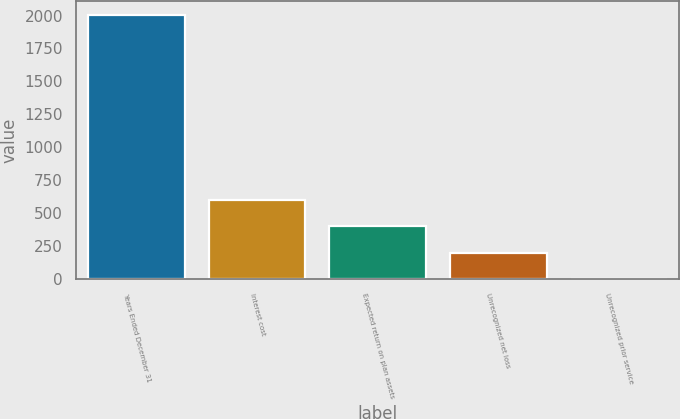Convert chart. <chart><loc_0><loc_0><loc_500><loc_500><bar_chart><fcel>Years Ended December 31<fcel>Interest cost<fcel>Expected return on plan assets<fcel>Unrecognized net loss<fcel>Unrecognized prior service<nl><fcel>2006<fcel>603.2<fcel>402.8<fcel>202.4<fcel>2<nl></chart> 